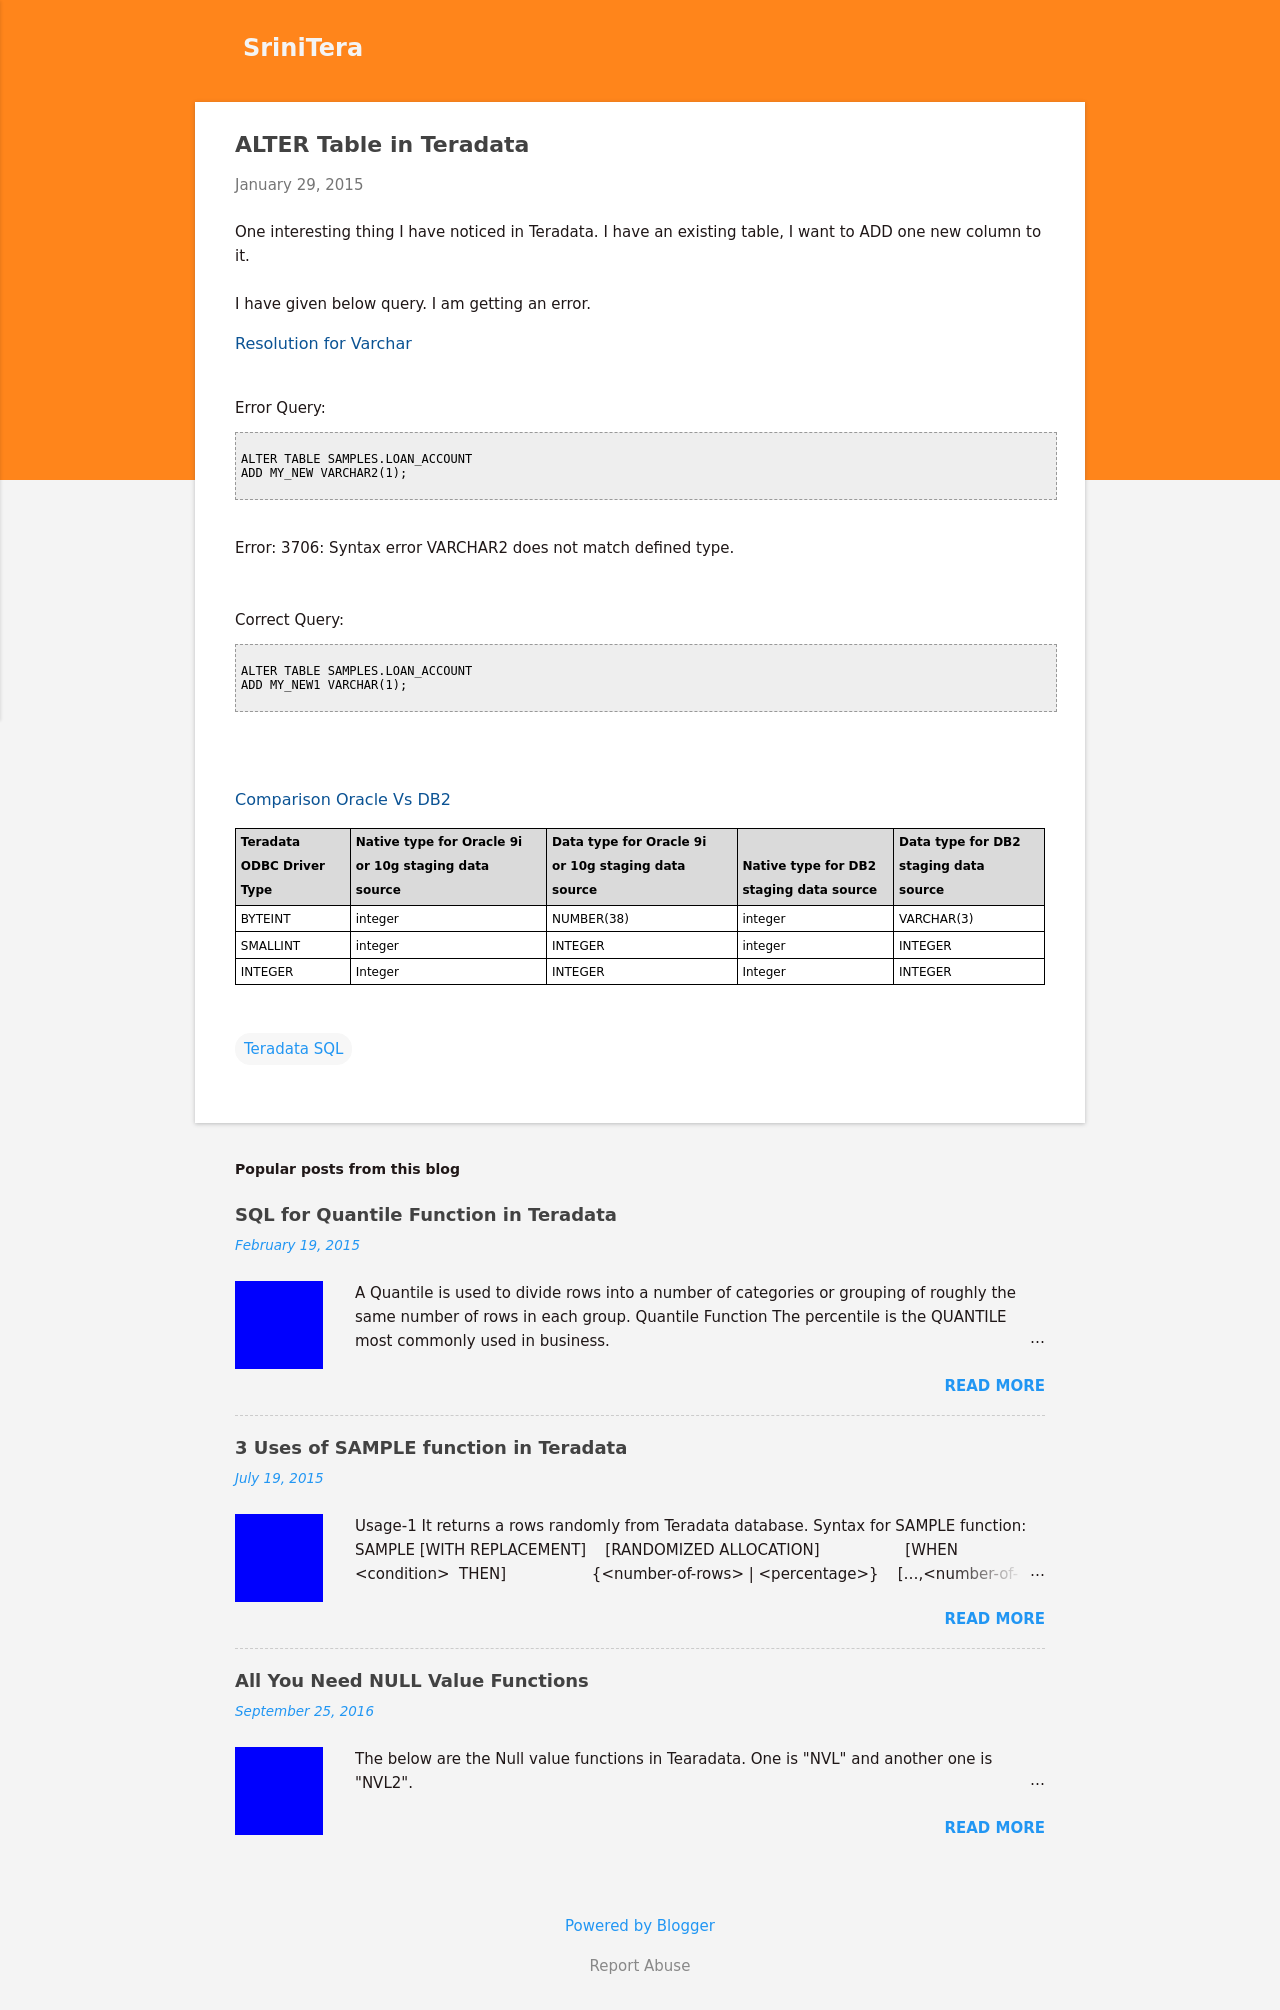What are the data types compared in the 'Comparison Oracle Vs DB2' section? The section compares various data types across Teradata, Oracle 9i or 10g, and DB2 staging data sources. It lists data types like BYTEINT, SMALLINT, and INTEGER, showing their equivalents in Oracle and DB2 which are important for ensuring data compatibility during migrations or integrations.  How does this information benefit database administrators? This information significantly aids database administrators in managing data migrations between different database systems. Knowing the equivalent data types ensures that data can be transferred accurately and efficiently without loss of integrity or functionality. 